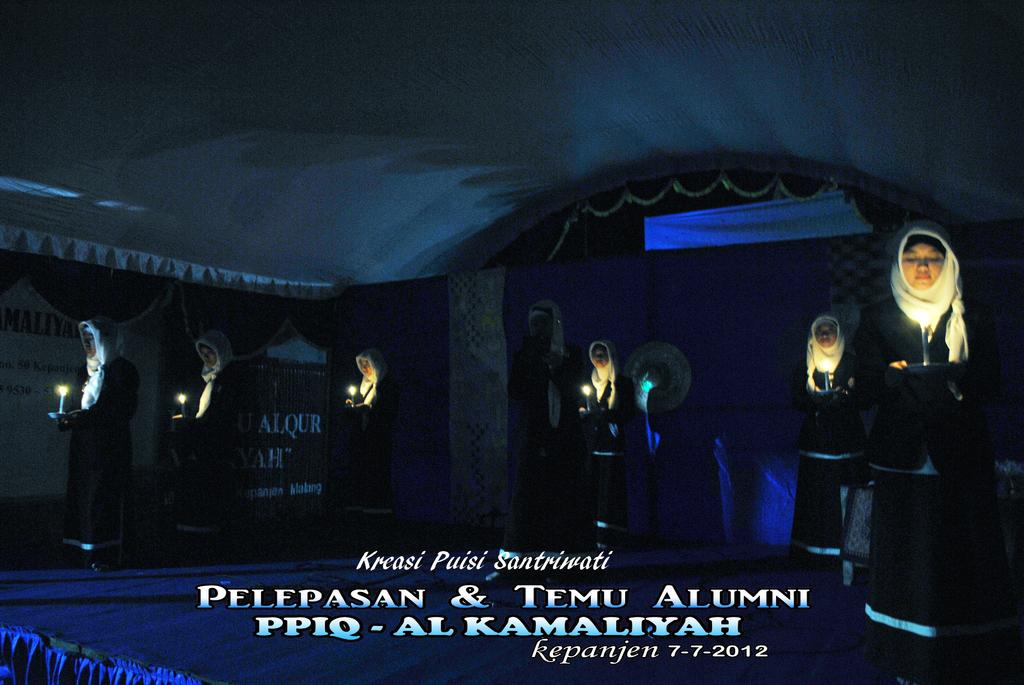Who is present in the image? There are women in the image. What are the women doing in the image? The women are standing and holding candles. What can be seen in the background of the image? There is a curtain and an advertisement in the background of the image. Is there any text present in the image? Yes, there is text at the bottom of the image. How many mice are running around the women's feet in the image? There are no mice present in the image; it only features women holding candles. 